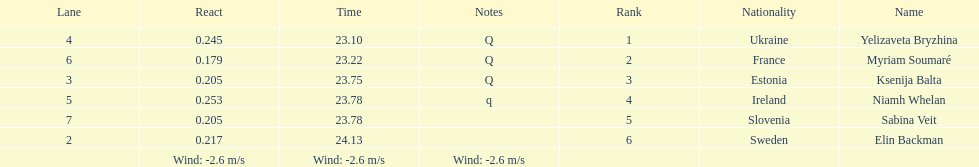Whose time is more than. 24.00? Elin Backman. 